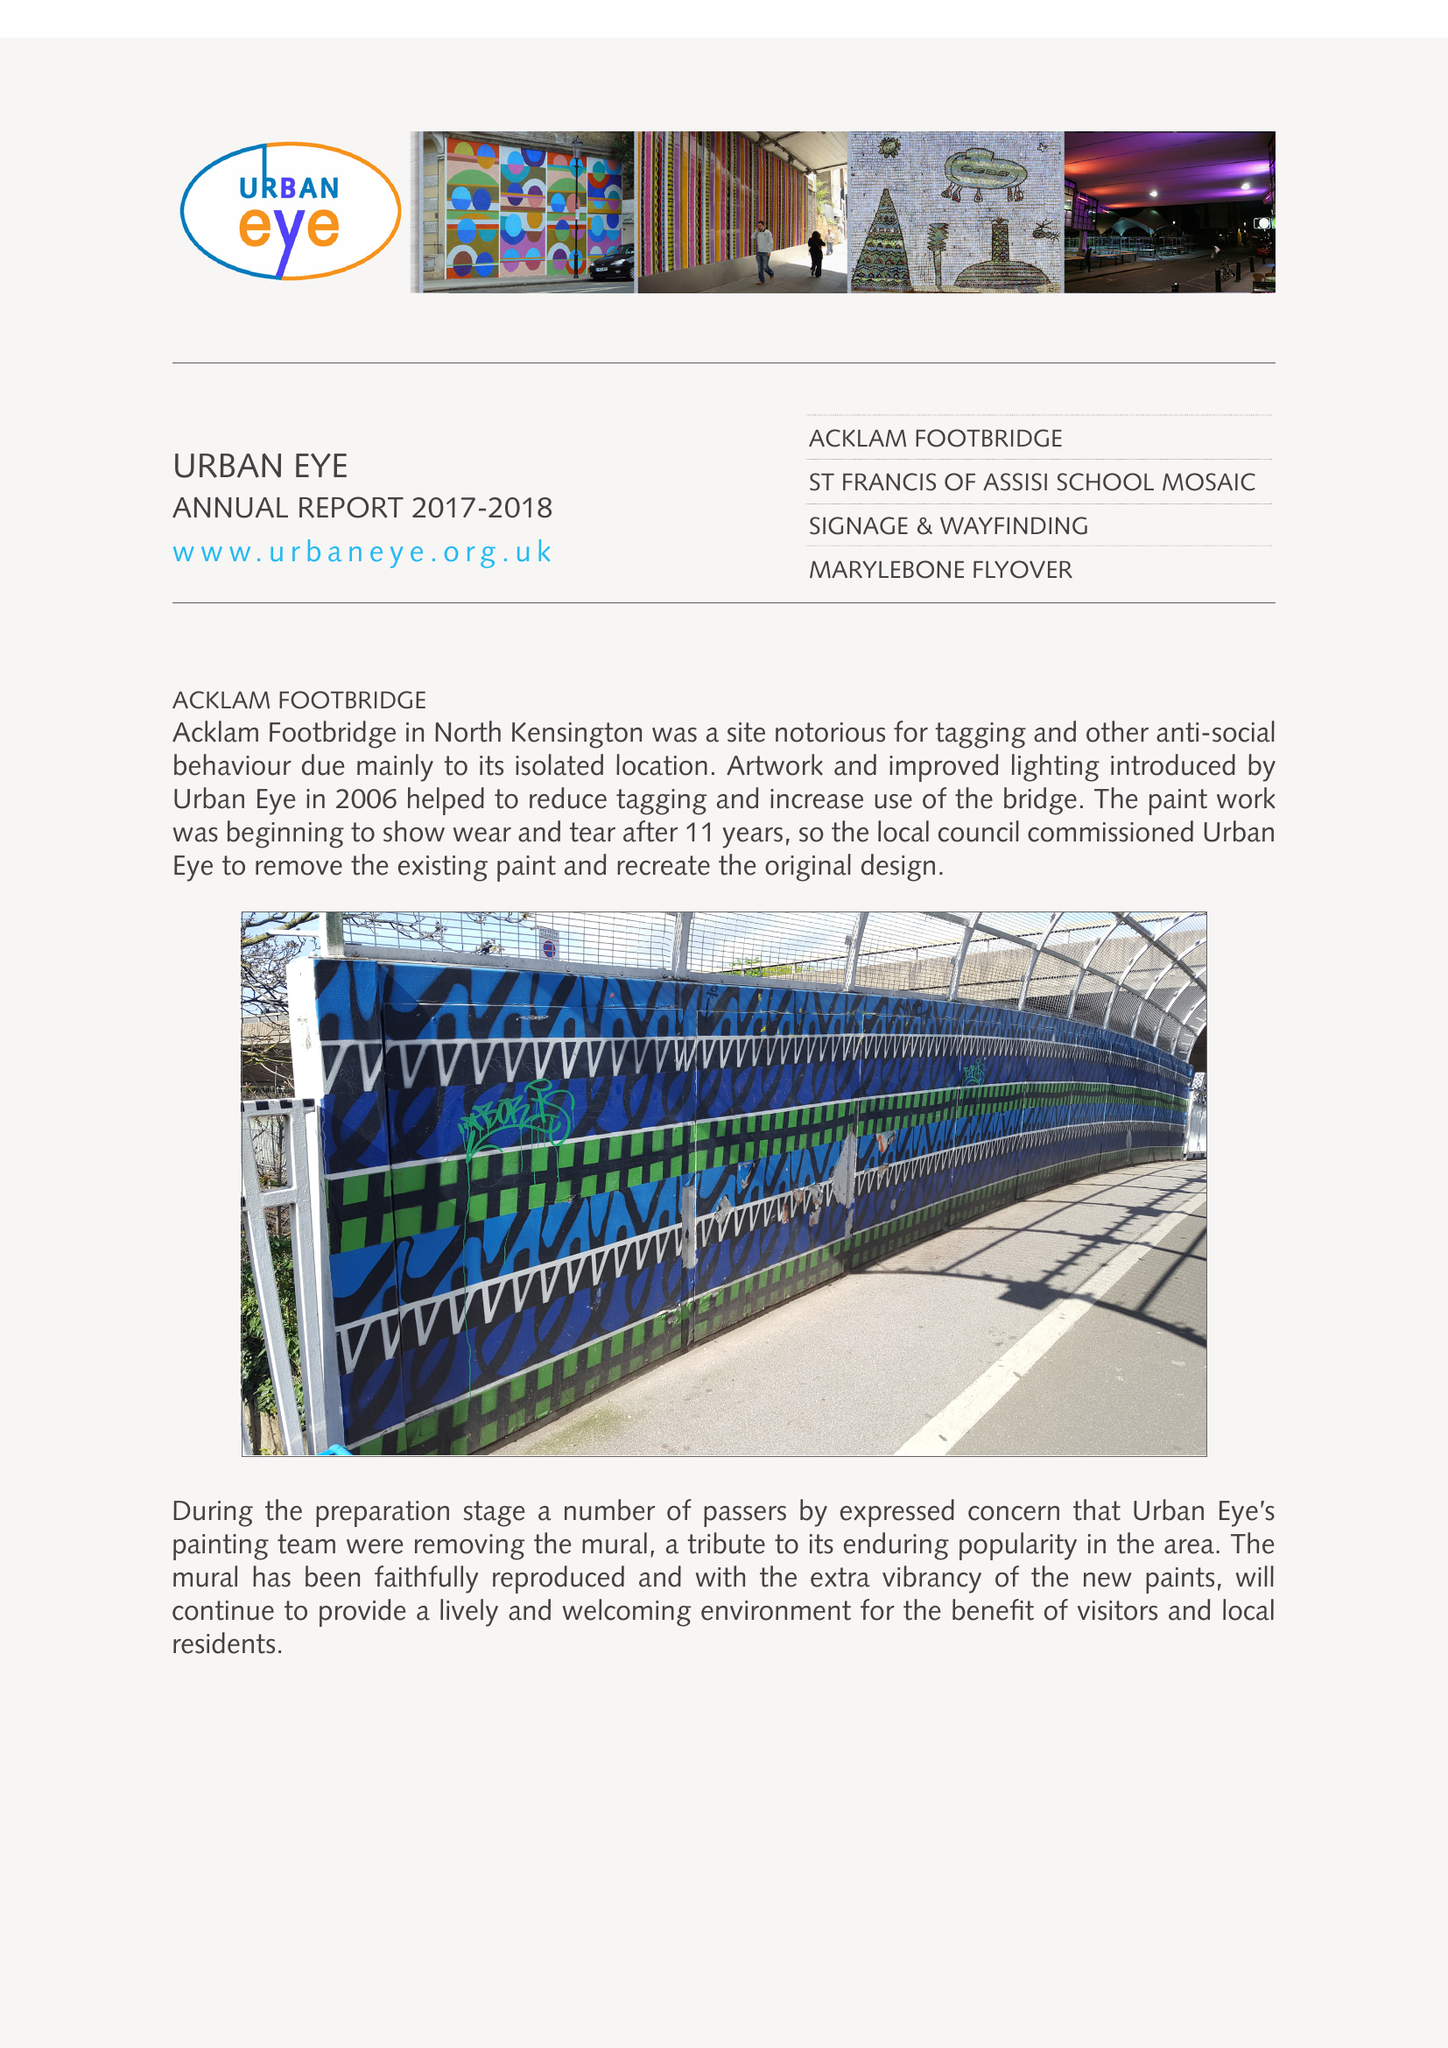What is the value for the charity_number?
Answer the question using a single word or phrase. 1089336 